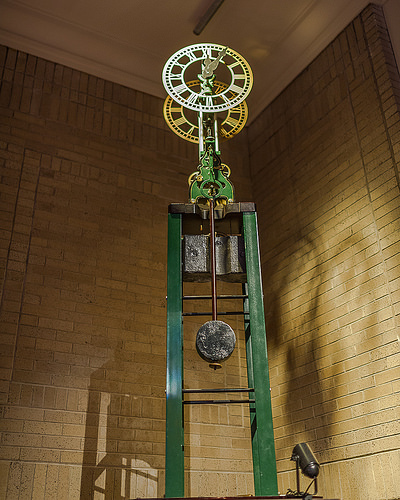<image>
Can you confirm if the gears is in the structure? Yes. The gears is contained within or inside the structure, showing a containment relationship. 